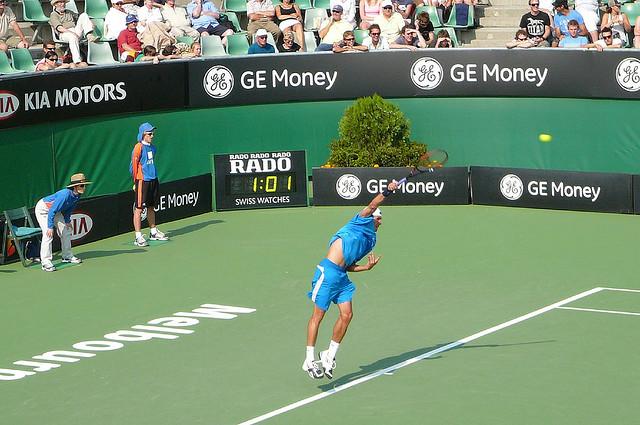What tournament cup are they playing for?
Be succinct. Melbourne. What sport is being played?
Short answer required. Tennis. What car company is advertised?
Answer briefly. Kia. 